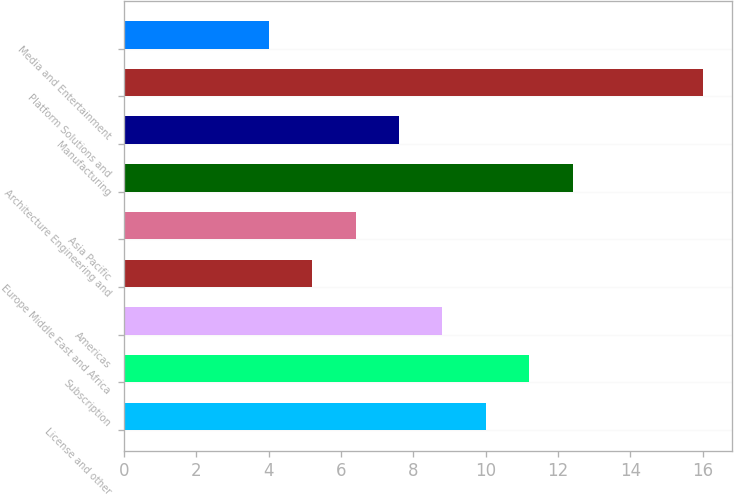Convert chart to OTSL. <chart><loc_0><loc_0><loc_500><loc_500><bar_chart><fcel>License and other<fcel>Subscription<fcel>Americas<fcel>Europe Middle East and Africa<fcel>Asia Pacific<fcel>Architecture Engineering and<fcel>Manufacturing<fcel>Platform Solutions and<fcel>Media and Entertainment<nl><fcel>10<fcel>11.2<fcel>8.8<fcel>5.2<fcel>6.4<fcel>12.4<fcel>7.6<fcel>16<fcel>4<nl></chart> 